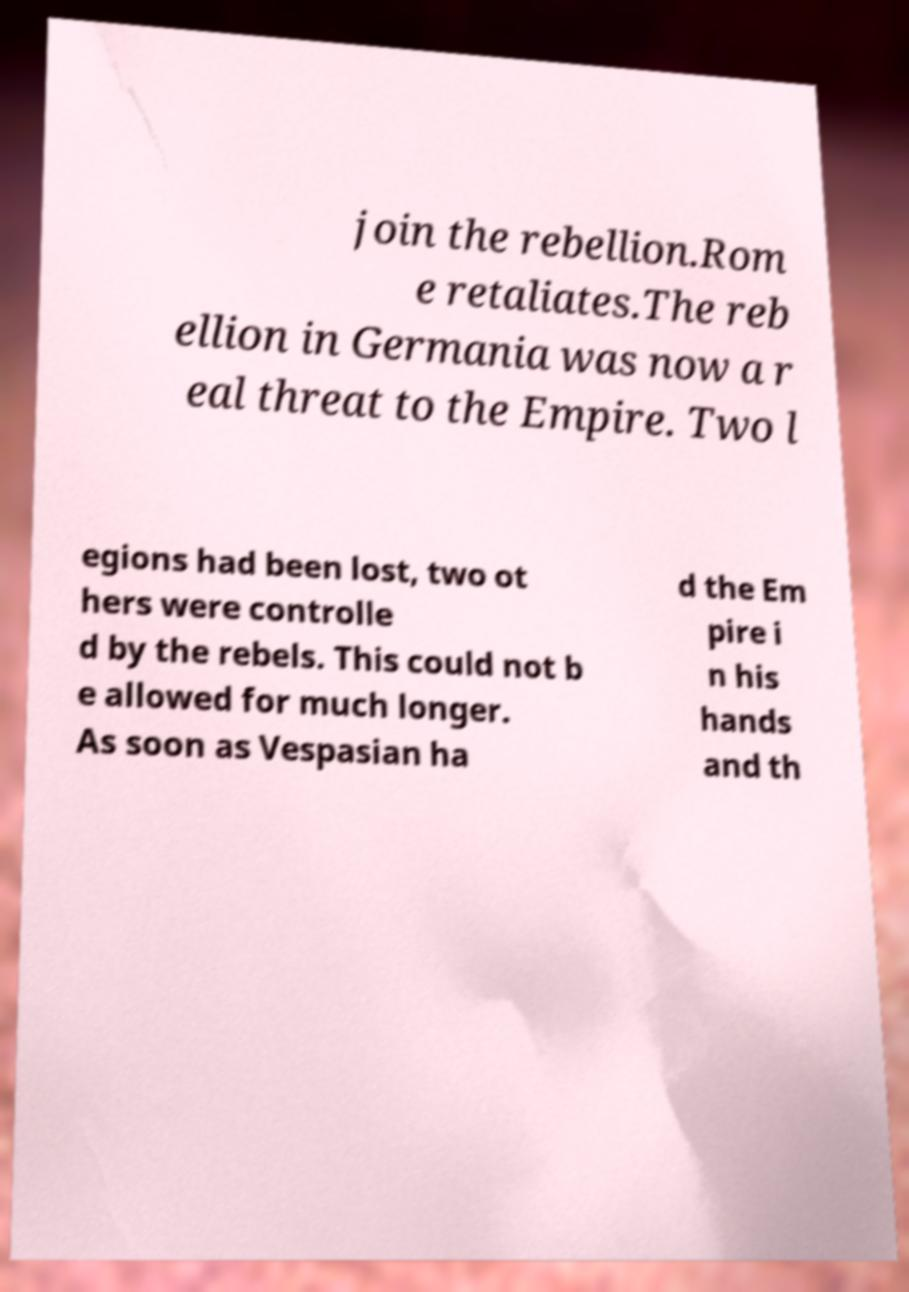For documentation purposes, I need the text within this image transcribed. Could you provide that? join the rebellion.Rom e retaliates.The reb ellion in Germania was now a r eal threat to the Empire. Two l egions had been lost, two ot hers were controlle d by the rebels. This could not b e allowed for much longer. As soon as Vespasian ha d the Em pire i n his hands and th 